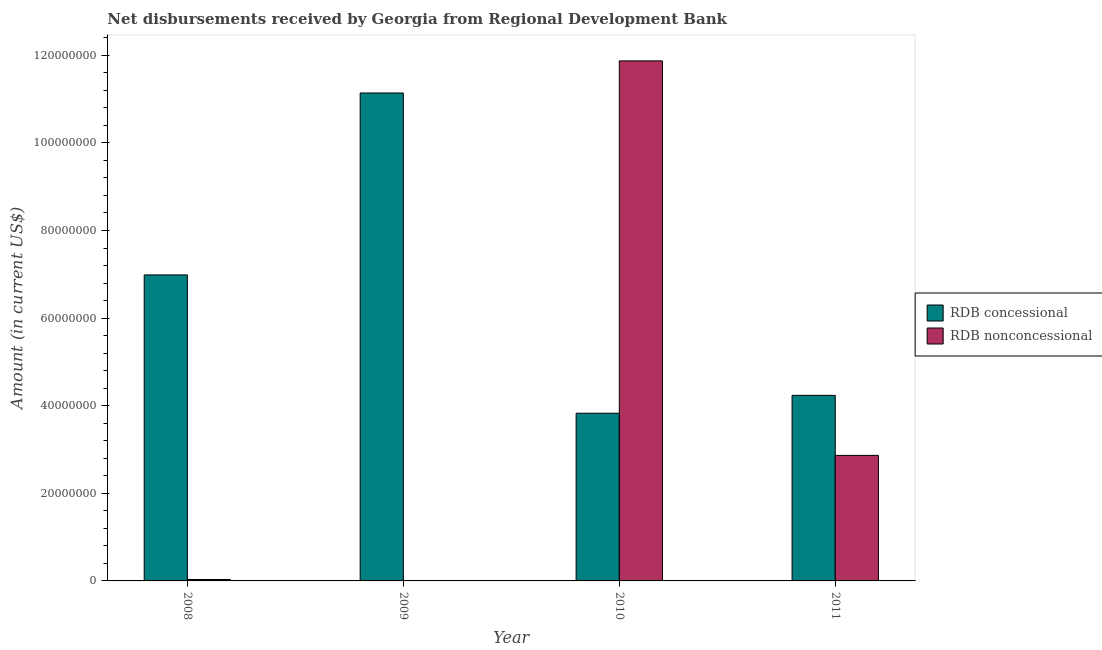Are the number of bars per tick equal to the number of legend labels?
Provide a short and direct response. No. Are the number of bars on each tick of the X-axis equal?
Make the answer very short. No. How many bars are there on the 3rd tick from the left?
Provide a short and direct response. 2. What is the net non concessional disbursements from rdb in 2010?
Give a very brief answer. 1.19e+08. Across all years, what is the maximum net concessional disbursements from rdb?
Offer a very short reply. 1.11e+08. Across all years, what is the minimum net concessional disbursements from rdb?
Make the answer very short. 3.83e+07. What is the total net concessional disbursements from rdb in the graph?
Your answer should be very brief. 2.62e+08. What is the difference between the net non concessional disbursements from rdb in 2008 and that in 2010?
Your response must be concise. -1.18e+08. What is the difference between the net non concessional disbursements from rdb in 2011 and the net concessional disbursements from rdb in 2008?
Keep it short and to the point. 2.83e+07. What is the average net non concessional disbursements from rdb per year?
Your answer should be compact. 3.69e+07. In the year 2008, what is the difference between the net concessional disbursements from rdb and net non concessional disbursements from rdb?
Your answer should be very brief. 0. In how many years, is the net non concessional disbursements from rdb greater than 72000000 US$?
Provide a succinct answer. 1. What is the ratio of the net concessional disbursements from rdb in 2008 to that in 2011?
Keep it short and to the point. 1.65. Is the net non concessional disbursements from rdb in 2008 less than that in 2011?
Your answer should be very brief. Yes. What is the difference between the highest and the second highest net concessional disbursements from rdb?
Your response must be concise. 4.15e+07. What is the difference between the highest and the lowest net concessional disbursements from rdb?
Keep it short and to the point. 7.31e+07. In how many years, is the net non concessional disbursements from rdb greater than the average net non concessional disbursements from rdb taken over all years?
Provide a short and direct response. 1. Is the sum of the net concessional disbursements from rdb in 2008 and 2011 greater than the maximum net non concessional disbursements from rdb across all years?
Offer a terse response. Yes. What is the difference between two consecutive major ticks on the Y-axis?
Make the answer very short. 2.00e+07. Are the values on the major ticks of Y-axis written in scientific E-notation?
Ensure brevity in your answer.  No. Does the graph contain grids?
Your answer should be very brief. No. Where does the legend appear in the graph?
Your answer should be compact. Center right. How many legend labels are there?
Provide a short and direct response. 2. What is the title of the graph?
Keep it short and to the point. Net disbursements received by Georgia from Regional Development Bank. Does "Old" appear as one of the legend labels in the graph?
Your response must be concise. No. What is the Amount (in current US$) in RDB concessional in 2008?
Keep it short and to the point. 6.99e+07. What is the Amount (in current US$) in RDB nonconcessional in 2008?
Provide a succinct answer. 3.26e+05. What is the Amount (in current US$) in RDB concessional in 2009?
Keep it short and to the point. 1.11e+08. What is the Amount (in current US$) in RDB concessional in 2010?
Offer a terse response. 3.83e+07. What is the Amount (in current US$) of RDB nonconcessional in 2010?
Offer a very short reply. 1.19e+08. What is the Amount (in current US$) of RDB concessional in 2011?
Offer a very short reply. 4.24e+07. What is the Amount (in current US$) in RDB nonconcessional in 2011?
Your answer should be compact. 2.87e+07. Across all years, what is the maximum Amount (in current US$) of RDB concessional?
Offer a very short reply. 1.11e+08. Across all years, what is the maximum Amount (in current US$) in RDB nonconcessional?
Provide a short and direct response. 1.19e+08. Across all years, what is the minimum Amount (in current US$) of RDB concessional?
Your answer should be compact. 3.83e+07. Across all years, what is the minimum Amount (in current US$) of RDB nonconcessional?
Give a very brief answer. 0. What is the total Amount (in current US$) in RDB concessional in the graph?
Your response must be concise. 2.62e+08. What is the total Amount (in current US$) in RDB nonconcessional in the graph?
Your answer should be very brief. 1.48e+08. What is the difference between the Amount (in current US$) of RDB concessional in 2008 and that in 2009?
Your answer should be very brief. -4.15e+07. What is the difference between the Amount (in current US$) of RDB concessional in 2008 and that in 2010?
Your answer should be compact. 3.16e+07. What is the difference between the Amount (in current US$) in RDB nonconcessional in 2008 and that in 2010?
Your answer should be compact. -1.18e+08. What is the difference between the Amount (in current US$) of RDB concessional in 2008 and that in 2011?
Give a very brief answer. 2.75e+07. What is the difference between the Amount (in current US$) of RDB nonconcessional in 2008 and that in 2011?
Offer a very short reply. -2.83e+07. What is the difference between the Amount (in current US$) of RDB concessional in 2009 and that in 2010?
Give a very brief answer. 7.31e+07. What is the difference between the Amount (in current US$) of RDB concessional in 2009 and that in 2011?
Offer a very short reply. 6.90e+07. What is the difference between the Amount (in current US$) in RDB concessional in 2010 and that in 2011?
Your response must be concise. -4.08e+06. What is the difference between the Amount (in current US$) in RDB nonconcessional in 2010 and that in 2011?
Provide a short and direct response. 9.01e+07. What is the difference between the Amount (in current US$) of RDB concessional in 2008 and the Amount (in current US$) of RDB nonconcessional in 2010?
Offer a very short reply. -4.89e+07. What is the difference between the Amount (in current US$) of RDB concessional in 2008 and the Amount (in current US$) of RDB nonconcessional in 2011?
Provide a short and direct response. 4.12e+07. What is the difference between the Amount (in current US$) of RDB concessional in 2009 and the Amount (in current US$) of RDB nonconcessional in 2010?
Offer a very short reply. -7.33e+06. What is the difference between the Amount (in current US$) of RDB concessional in 2009 and the Amount (in current US$) of RDB nonconcessional in 2011?
Give a very brief answer. 8.27e+07. What is the difference between the Amount (in current US$) of RDB concessional in 2010 and the Amount (in current US$) of RDB nonconcessional in 2011?
Ensure brevity in your answer.  9.62e+06. What is the average Amount (in current US$) of RDB concessional per year?
Keep it short and to the point. 6.55e+07. What is the average Amount (in current US$) in RDB nonconcessional per year?
Your answer should be very brief. 3.69e+07. In the year 2008, what is the difference between the Amount (in current US$) of RDB concessional and Amount (in current US$) of RDB nonconcessional?
Your answer should be very brief. 6.95e+07. In the year 2010, what is the difference between the Amount (in current US$) in RDB concessional and Amount (in current US$) in RDB nonconcessional?
Your answer should be compact. -8.04e+07. In the year 2011, what is the difference between the Amount (in current US$) in RDB concessional and Amount (in current US$) in RDB nonconcessional?
Your answer should be very brief. 1.37e+07. What is the ratio of the Amount (in current US$) in RDB concessional in 2008 to that in 2009?
Provide a short and direct response. 0.63. What is the ratio of the Amount (in current US$) in RDB concessional in 2008 to that in 2010?
Keep it short and to the point. 1.82. What is the ratio of the Amount (in current US$) of RDB nonconcessional in 2008 to that in 2010?
Keep it short and to the point. 0. What is the ratio of the Amount (in current US$) of RDB concessional in 2008 to that in 2011?
Your answer should be very brief. 1.65. What is the ratio of the Amount (in current US$) of RDB nonconcessional in 2008 to that in 2011?
Provide a short and direct response. 0.01. What is the ratio of the Amount (in current US$) of RDB concessional in 2009 to that in 2010?
Give a very brief answer. 2.91. What is the ratio of the Amount (in current US$) of RDB concessional in 2009 to that in 2011?
Your response must be concise. 2.63. What is the ratio of the Amount (in current US$) in RDB concessional in 2010 to that in 2011?
Your answer should be compact. 0.9. What is the ratio of the Amount (in current US$) of RDB nonconcessional in 2010 to that in 2011?
Keep it short and to the point. 4.14. What is the difference between the highest and the second highest Amount (in current US$) in RDB concessional?
Provide a short and direct response. 4.15e+07. What is the difference between the highest and the second highest Amount (in current US$) in RDB nonconcessional?
Offer a very short reply. 9.01e+07. What is the difference between the highest and the lowest Amount (in current US$) in RDB concessional?
Your response must be concise. 7.31e+07. What is the difference between the highest and the lowest Amount (in current US$) of RDB nonconcessional?
Provide a short and direct response. 1.19e+08. 